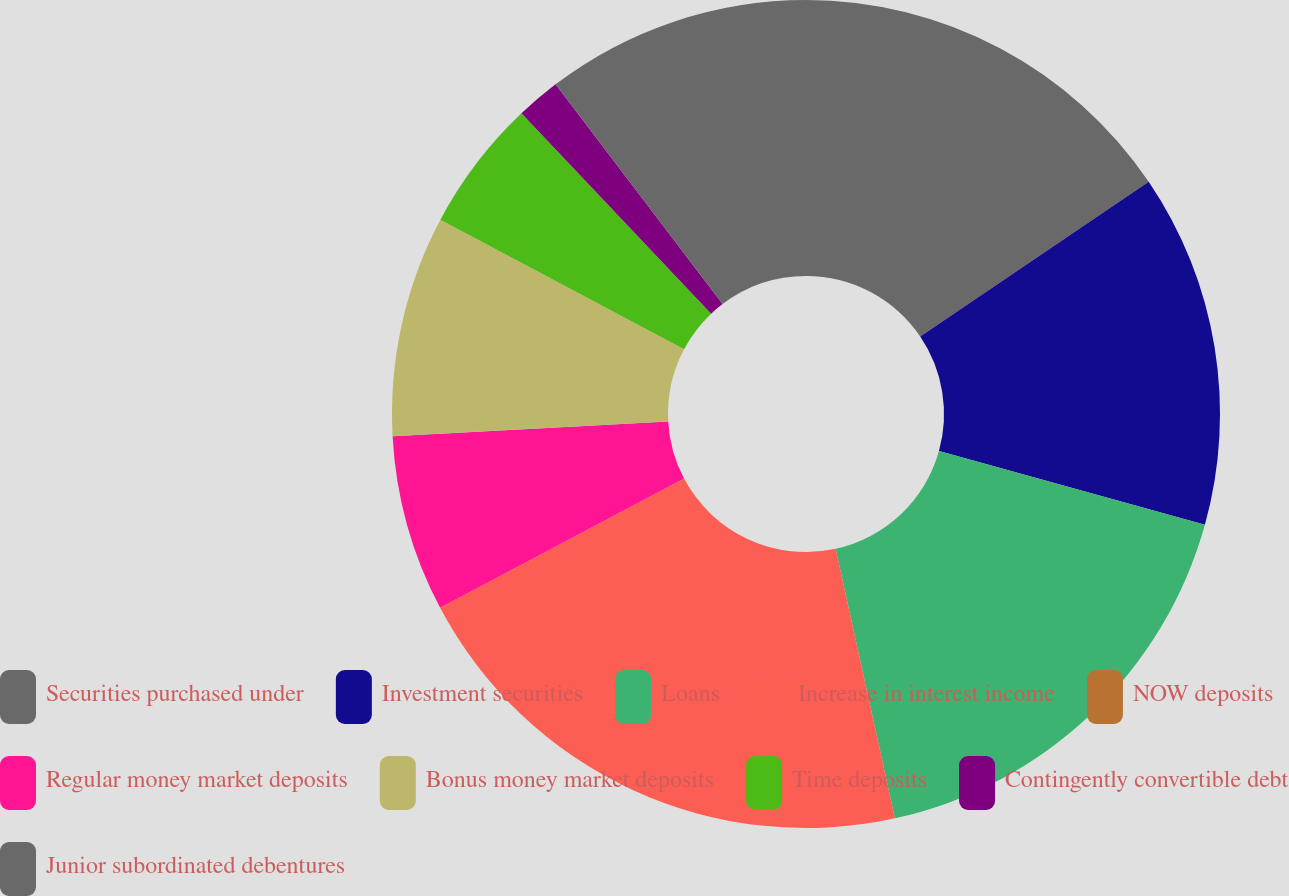<chart> <loc_0><loc_0><loc_500><loc_500><pie_chart><fcel>Securities purchased under<fcel>Investment securities<fcel>Loans<fcel>Increase in interest income<fcel>NOW deposits<fcel>Regular money market deposits<fcel>Bonus money market deposits<fcel>Time deposits<fcel>Contingently convertible debt<fcel>Junior subordinated debentures<nl><fcel>15.52%<fcel>13.79%<fcel>17.24%<fcel>20.69%<fcel>0.0%<fcel>6.9%<fcel>8.62%<fcel>5.17%<fcel>1.72%<fcel>10.34%<nl></chart> 